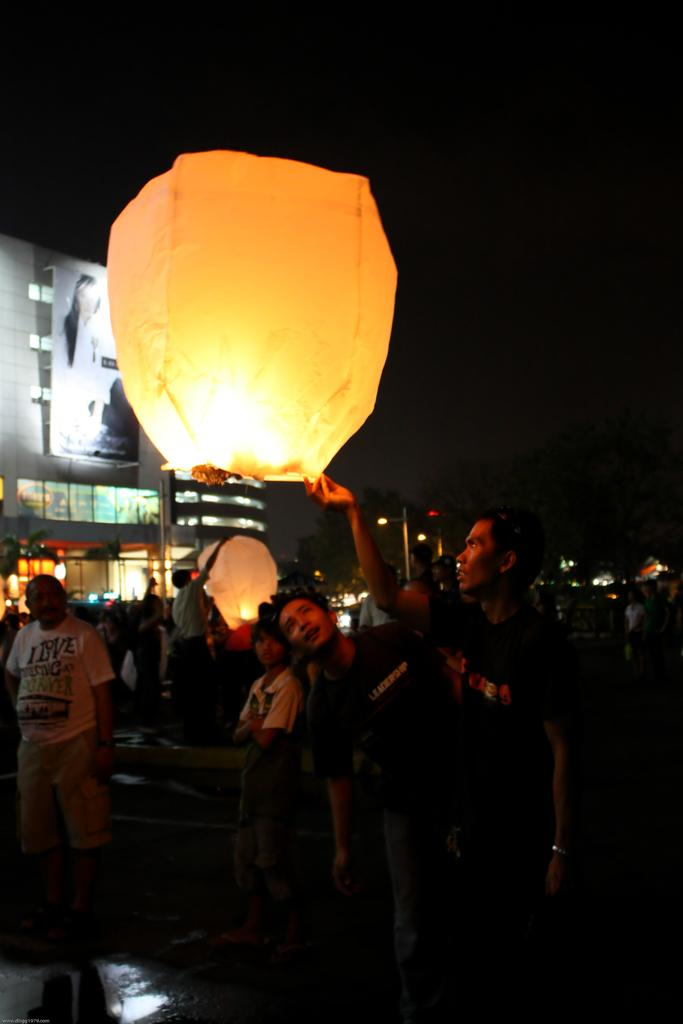How many people are in the image? There is a group of people in the image, but the exact number cannot be determined from the provided facts. What type of lighting is present in the image? There are lanterns, lights, and a dark background in the image. What structure can be seen in the image? There is a building in the image. What is hanging in the image? There is a banner in the image. What other objects can be seen in the image? There are some objects in the image, but their specific nature cannot be determined from the provided facts. How many trees can be seen with their branches covered in cobwebs in the image? There are no trees or cobwebs present in the image. What type of nail is being used to hang the banner in the image? There is no mention of a nail being used to hang the banner in the image. 